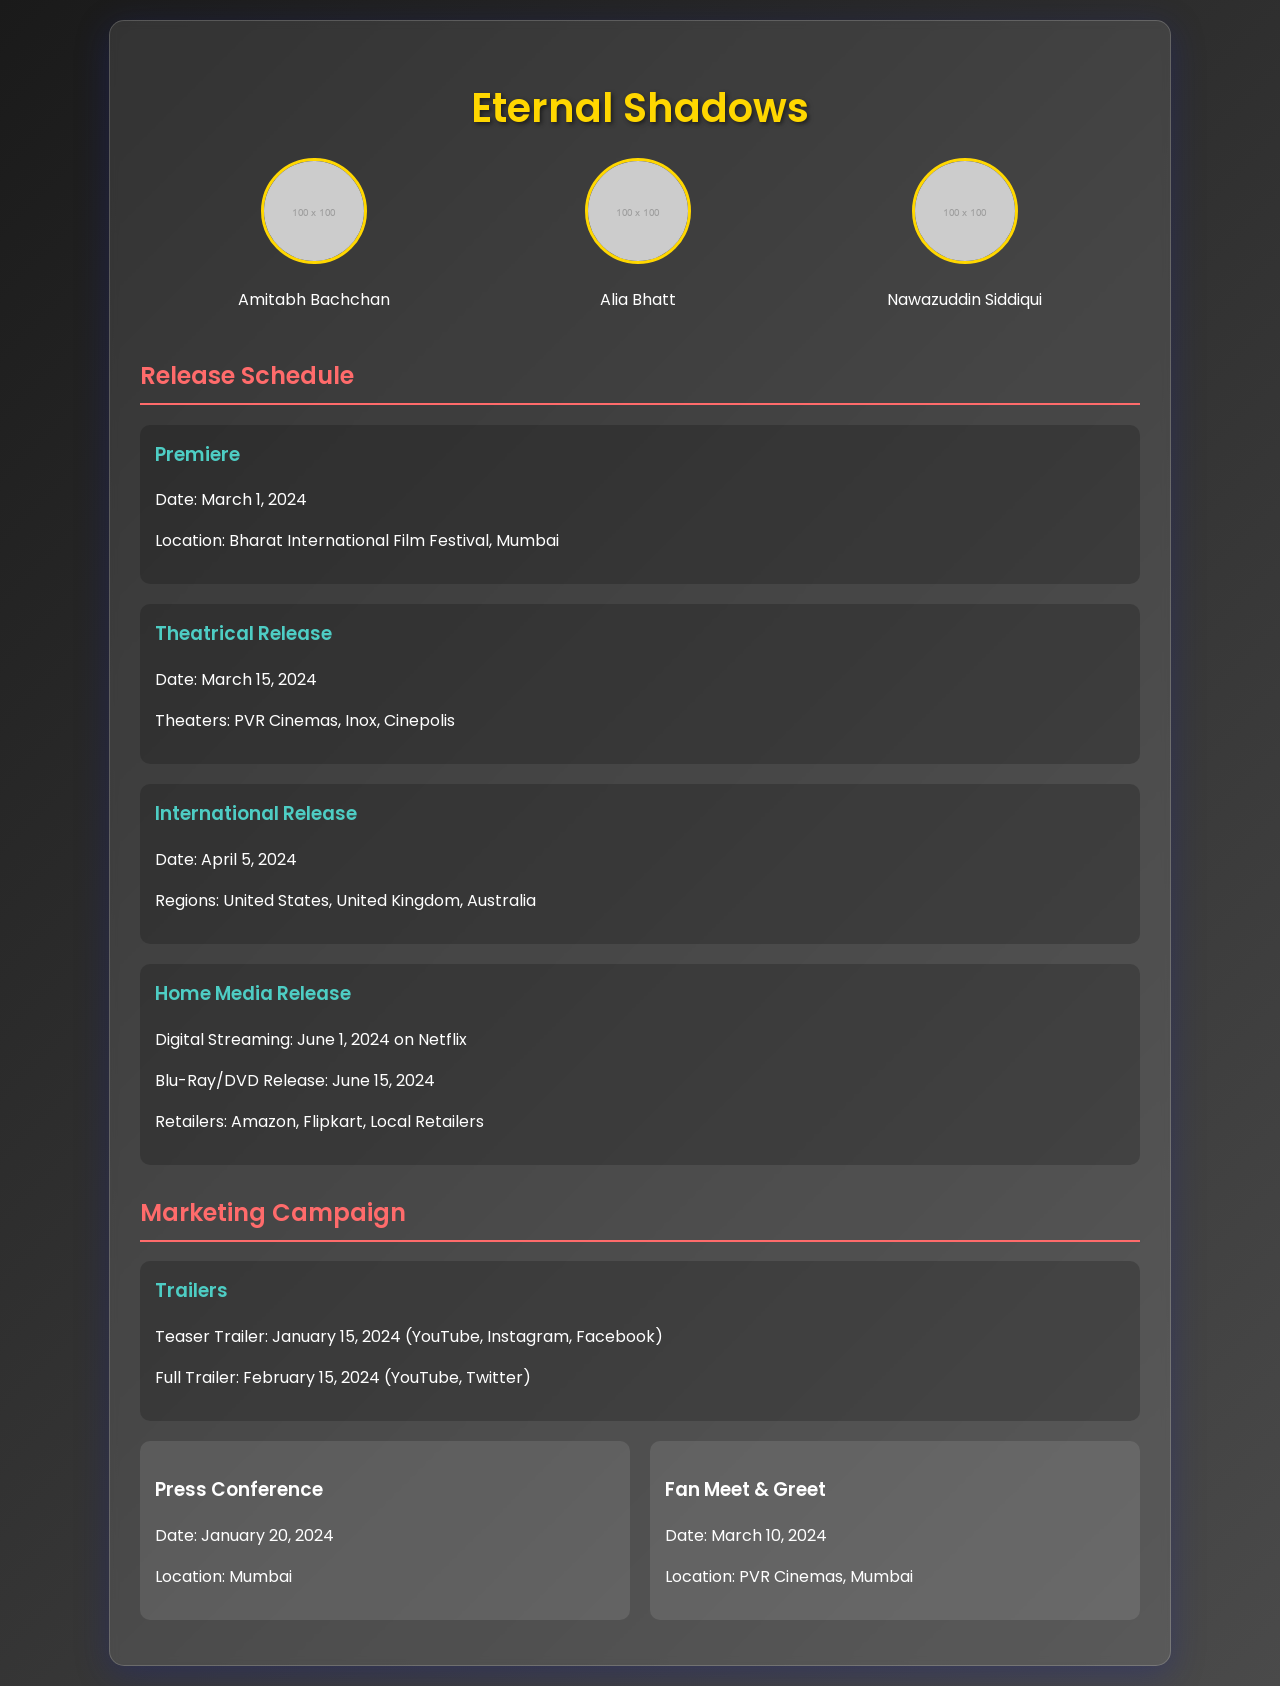What is the premiere date of the film? The premiere date can be found in the release schedule section, specifically listed under "Premiere".
Answer: March 1, 2024 Where will the premiere take place? The location of the premiere is indicated in the release schedule section, specifically under "Premiere".
Answer: Bharat International Film Festival, Mumbai What date does the theatrical release occur? The date for the theatrical release is mentioned in the release schedule section under "Theatrical Release".
Answer: March 15, 2024 When is the digital streaming release on Netflix? The digital streaming release is specified in the release schedule section under "Home Media Release".
Answer: June 1, 2024 How many main actors are featured in the star cast? The number of main actors can be deduced from the star cast section where their names and images are displayed.
Answer: 3 What is the date of the press conference? The date for the press conference is found in the marketing campaign section under "Press Conference".
Answer: January 20, 2024 Which retailers will offer the Blu-Ray/DVD release? The retailers for the home media release are listed in the release schedule section under "Home Media Release".
Answer: Amazon, Flipkart, Local Retailers What is the release date for the full trailer? The release date for the full trailer is mentioned in the marketing campaign section under "Trailers".
Answer: February 15, 2024 In which regions will the international release occur? The regions for the international release are found in the release schedule section under "International Release".
Answer: United States, United Kingdom, Australia 